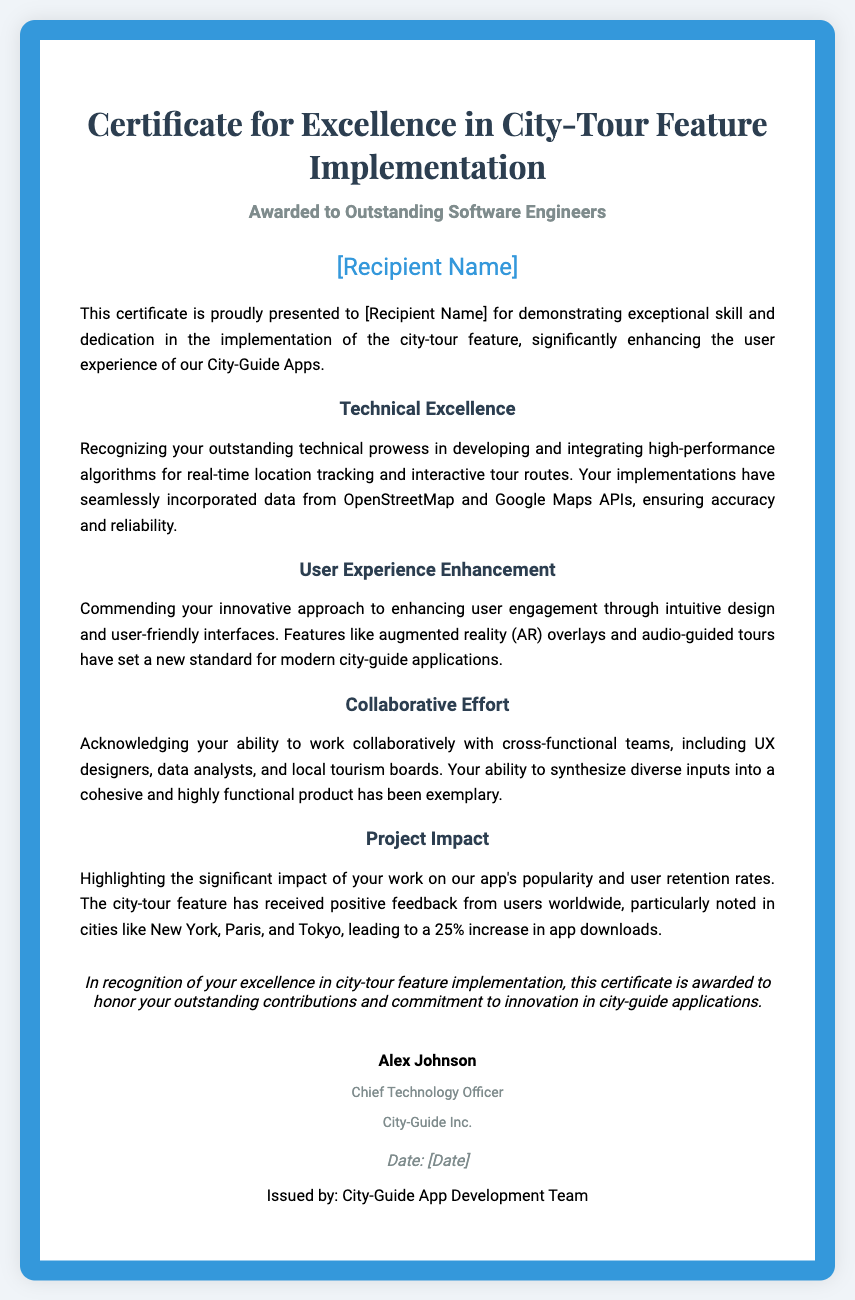What is the title of the certificate? The title of the certificate highlights its purpose, which is "Certificate for Excellence in City-Tour Feature Implementation."
Answer: Certificate for Excellence in City-Tour Feature Implementation Who is the certificate awarded to? The document space for the recipient's name indicates that it is awarded to "[Recipient Name]."
Answer: [Recipient Name] What position does the signer hold? The signer of the certificate is identified as the "Chief Technology Officer."
Answer: Chief Technology Officer What is the main focus of the certificate? The focus of the certificate is on the implementation of the city-tour feature that enhances user experience in applications.
Answer: City-tour feature implementation What percentage increase in app downloads is mentioned? The document specifies a 25% increase in app downloads.
Answer: 25% List one technology integrated into the tour feature implementation. The document mentions "OpenStreetMap and Google Maps APIs" as technologies used.
Answer: OpenStreetMap and Google Maps APIs What kind of team collaboration is acknowledged? The certificate acknowledges the ability to work collaboratively with "cross-functional teams."
Answer: Cross-functional teams What notable cities are mentioned for user feedback? The cities noted for positive feedback include New York, Paris, and Tokyo.
Answer: New York, Paris, Tokyo When was the certificate issued? The document includes a space for a date, indicated by "[Date]."
Answer: [Date] 